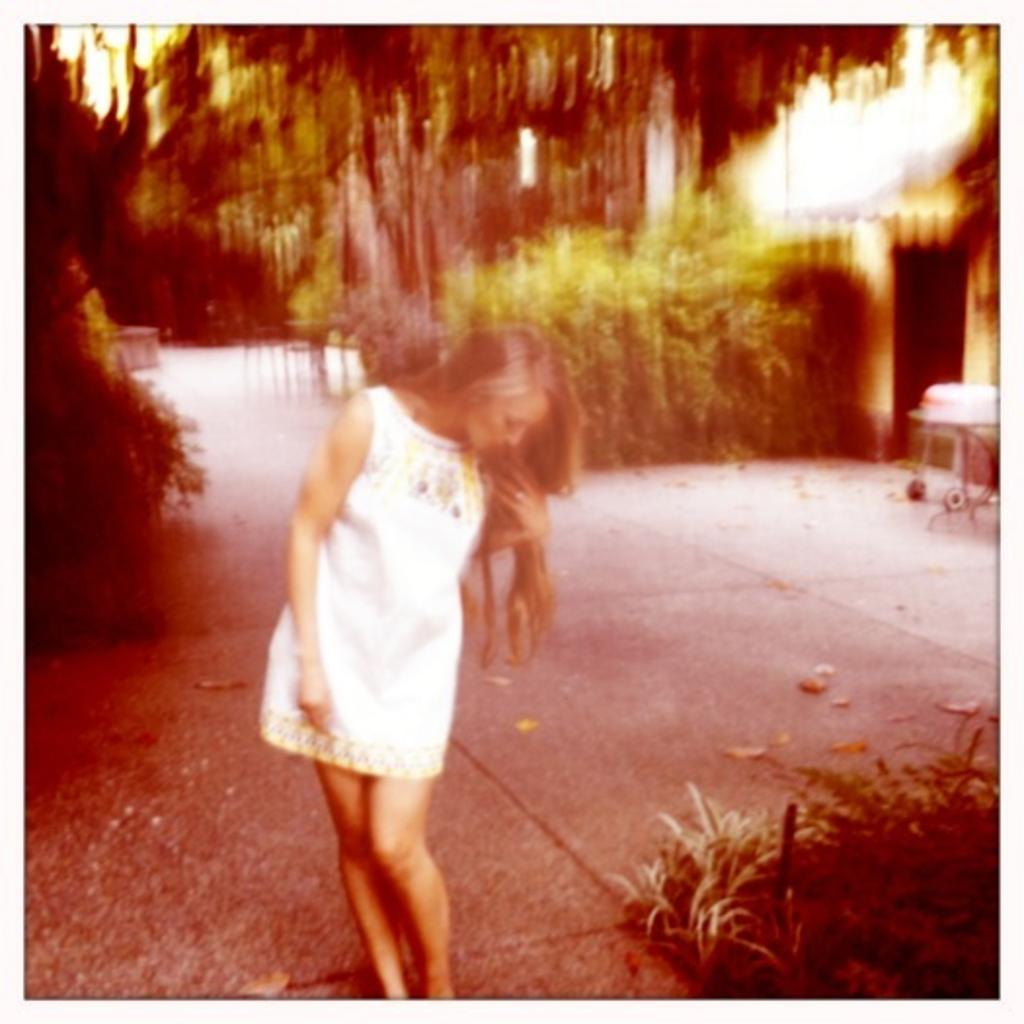Who is present in the image? There is a woman in the image. What is the woman wearing? The woman is wearing a white dress. Where is the woman located in the image? The woman is standing on the road. What type of vegetation can be seen in the image? There is grass visible in the image. What else can be seen in the image besides the woman and the grass? There are objects and trees in the background of the image. What scent can be detected from the woman in the image? There is no information about the scent of the woman in the image, as it is a visual medium. 